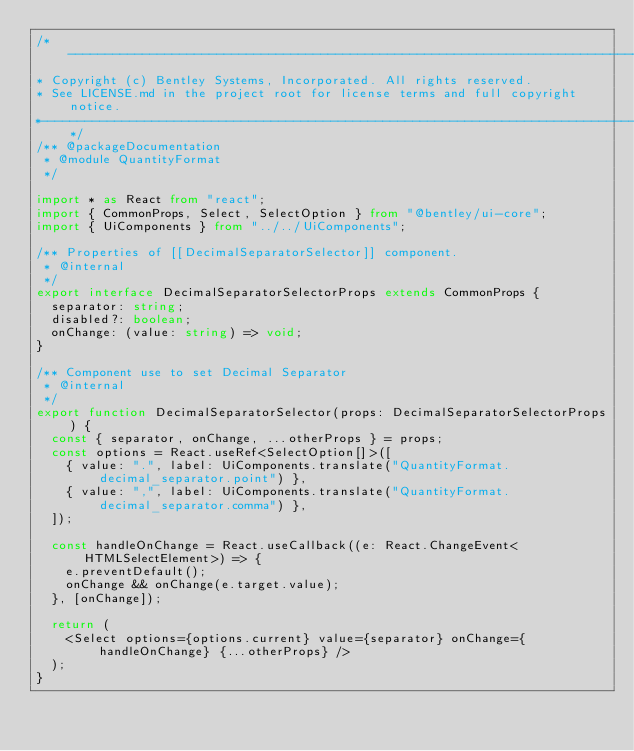<code> <loc_0><loc_0><loc_500><loc_500><_TypeScript_>/*---------------------------------------------------------------------------------------------
* Copyright (c) Bentley Systems, Incorporated. All rights reserved.
* See LICENSE.md in the project root for license terms and full copyright notice.
*--------------------------------------------------------------------------------------------*/
/** @packageDocumentation
 * @module QuantityFormat
 */

import * as React from "react";
import { CommonProps, Select, SelectOption } from "@bentley/ui-core";
import { UiComponents } from "../../UiComponents";

/** Properties of [[DecimalSeparatorSelector]] component.
 * @internal
 */
export interface DecimalSeparatorSelectorProps extends CommonProps {
  separator: string;
  disabled?: boolean;
  onChange: (value: string) => void;
}

/** Component use to set Decimal Separator
 * @internal
 */
export function DecimalSeparatorSelector(props: DecimalSeparatorSelectorProps) {
  const { separator, onChange, ...otherProps } = props;
  const options = React.useRef<SelectOption[]>([
    { value: ".", label: UiComponents.translate("QuantityFormat.decimal_separator.point") },
    { value: ",", label: UiComponents.translate("QuantityFormat.decimal_separator.comma") },
  ]);

  const handleOnChange = React.useCallback((e: React.ChangeEvent<HTMLSelectElement>) => {
    e.preventDefault();
    onChange && onChange(e.target.value);
  }, [onChange]);

  return (
    <Select options={options.current} value={separator} onChange={handleOnChange} {...otherProps} />
  );
}
</code> 